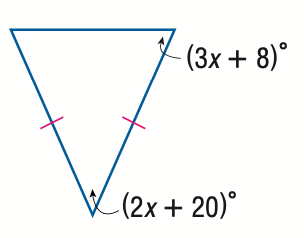Question: Find x.
Choices:
A. 12
B. 18
C. 18.9
D. 28
Answer with the letter. Answer: B 